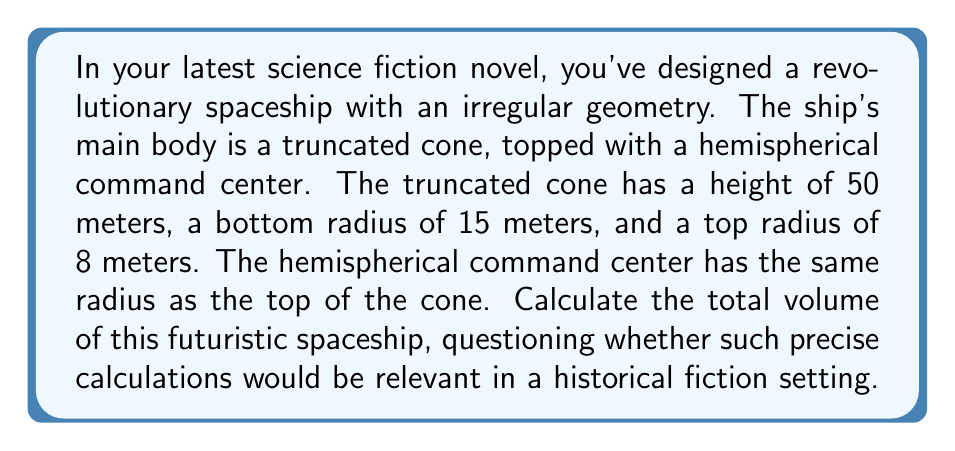Show me your answer to this math problem. To solve this problem, we need to calculate the volumes of two components: the truncated cone and the hemisphere, then add them together.

1. Volume of the truncated cone:
The formula for the volume of a truncated cone is:

$$V_{cone} = \frac{1}{3}\pi h(R^2 + r^2 + Rr)$$

Where $h$ is the height, $R$ is the radius of the base, and $r$ is the radius of the top.

Substituting our values:
$$V_{cone} = \frac{1}{3}\pi \cdot 50(15^2 + 8^2 + 15 \cdot 8)$$
$$V_{cone} = \frac{1}{3}\pi \cdot 50(225 + 64 + 120)$$
$$V_{cone} = \frac{1}{3}\pi \cdot 50 \cdot 409$$
$$V_{cone} = 10725\frac{2}{3}\pi$$

2. Volume of the hemisphere:
The formula for the volume of a hemisphere is:

$$V_{hemisphere} = \frac{2}{3}\pi r^3$$

Where $r$ is the radius of the hemisphere (8 meters in this case).

$$V_{hemisphere} = \frac{2}{3}\pi \cdot 8^3$$
$$V_{hemisphere} = \frac{2}{3}\pi \cdot 512$$
$$V_{hemisphere} = 341\frac{1}{3}\pi$$

3. Total volume:
$$V_{total} = V_{cone} + V_{hemisphere}$$
$$V_{total} = 10725\frac{2}{3}\pi + 341\frac{1}{3}\pi$$
$$V_{total} = 11067\pi$$

Therefore, the total volume of the spaceship is $11067\pi$ cubic meters.

[asy]
import geometry;

size(200);

// Draw truncated cone
path p = (15,0)--(15,50)--(8,50)--(0,0)--cycle;
fill(p,lightgray);
draw(p);

// Draw hemisphere
path q = arc((8,50),8,0,180);
fill(q--cycle,lightgray);
draw(q);

// Labels
label("50m",(-2,25),W);
label("15m",(7.5,0),S);
label("8m",(4,50),N);

// Dotted lines
draw((0,0)--(0,50),dotted);
draw((15,0)--(15,50),dotted);
draw((8,50)--(8,58),dotted);
[/asy]
Answer: The total volume of the futuristic spaceship is $11067\pi$ cubic meters, or approximately 34,770.8 cubic meters. 